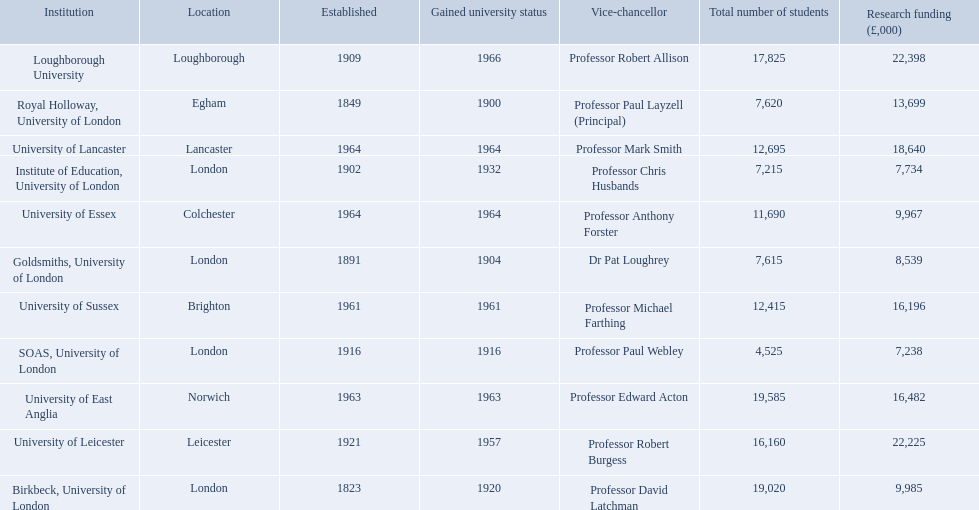What are the names of all the institutions? Birkbeck, University of London, University of East Anglia, University of Essex, Goldsmiths, University of London, Institute of Education, University of London, University of Lancaster, University of Leicester, Loughborough University, Royal Holloway, University of London, SOAS, University of London, University of Sussex. In what range of years were these institutions established? 1823, 1963, 1964, 1891, 1902, 1964, 1921, 1909, 1849, 1916, 1961. In what range of years did these institutions gain university status? 1920, 1963, 1964, 1904, 1932, 1964, 1957, 1966, 1900, 1916, 1961. What institution most recently gained university status? Loughborough University. 